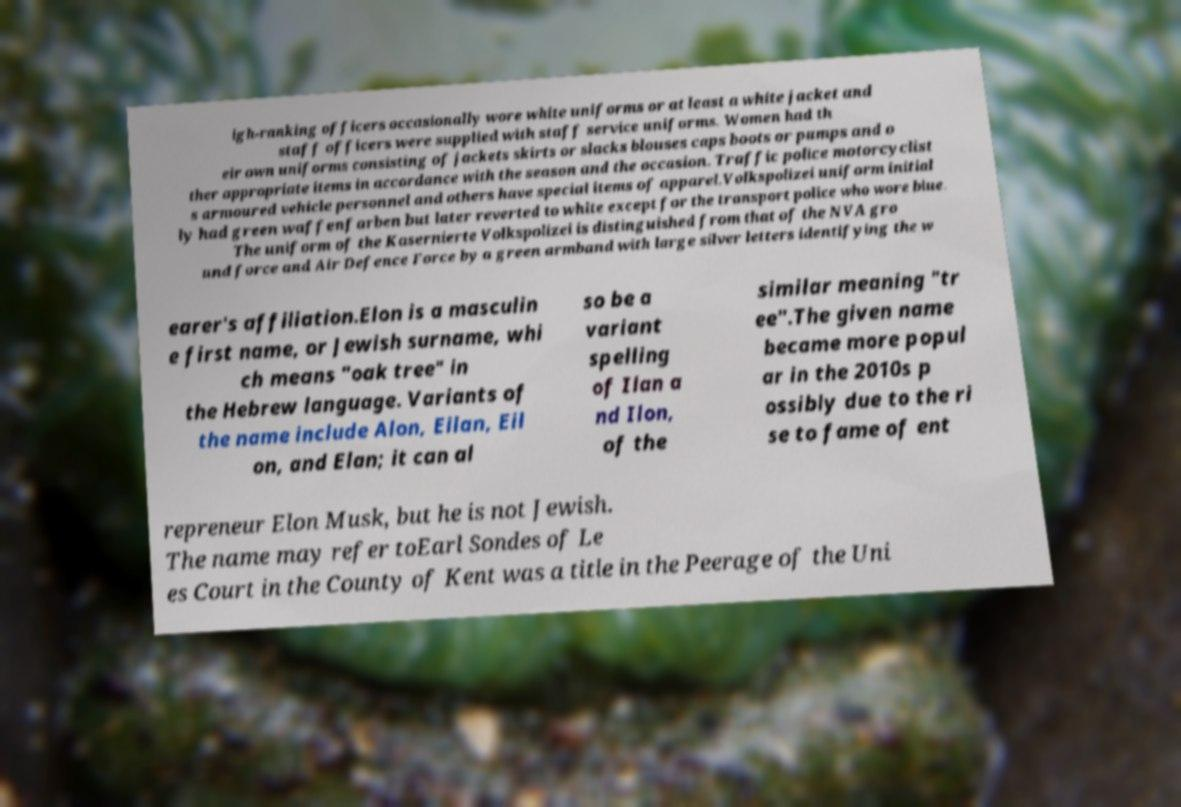Can you accurately transcribe the text from the provided image for me? igh-ranking officers occasionally wore white uniforms or at least a white jacket and staff officers were supplied with staff service uniforms. Women had th eir own uniforms consisting of jackets skirts or slacks blouses caps boots or pumps and o ther appropriate items in accordance with the season and the occasion. Traffic police motorcyclist s armoured vehicle personnel and others have special items of apparel.Volkspolizei uniform initial ly had green waffenfarben but later reverted to white except for the transport police who wore blue. The uniform of the Kasernierte Volkspolizei is distinguished from that of the NVA gro und force and Air Defence Force by a green armband with large silver letters identifying the w earer's affiliation.Elon is a masculin e first name, or Jewish surname, whi ch means "oak tree" in the Hebrew language. Variants of the name include Alon, Eilan, Eil on, and Elan; it can al so be a variant spelling of Ilan a nd Ilon, of the similar meaning "tr ee".The given name became more popul ar in the 2010s p ossibly due to the ri se to fame of ent repreneur Elon Musk, but he is not Jewish. The name may refer toEarl Sondes of Le es Court in the County of Kent was a title in the Peerage of the Uni 